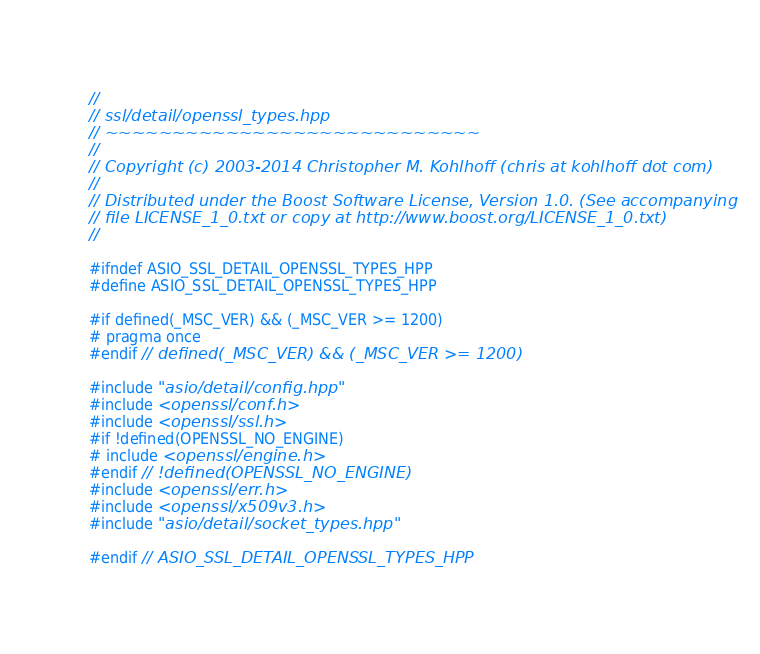<code> <loc_0><loc_0><loc_500><loc_500><_C++_>//
// ssl/detail/openssl_types.hpp
// ~~~~~~~~~~~~~~~~~~~~~~~~~~~~
//
// Copyright (c) 2003-2014 Christopher M. Kohlhoff (chris at kohlhoff dot com)
//
// Distributed under the Boost Software License, Version 1.0. (See accompanying
// file LICENSE_1_0.txt or copy at http://www.boost.org/LICENSE_1_0.txt)
//

#ifndef ASIO_SSL_DETAIL_OPENSSL_TYPES_HPP
#define ASIO_SSL_DETAIL_OPENSSL_TYPES_HPP

#if defined(_MSC_VER) && (_MSC_VER >= 1200)
# pragma once
#endif // defined(_MSC_VER) && (_MSC_VER >= 1200)

#include "asio/detail/config.hpp"
#include <openssl/conf.h>
#include <openssl/ssl.h>
#if !defined(OPENSSL_NO_ENGINE)
# include <openssl/engine.h>
#endif // !defined(OPENSSL_NO_ENGINE)
#include <openssl/err.h>
#include <openssl/x509v3.h>
#include "asio/detail/socket_types.hpp"

#endif // ASIO_SSL_DETAIL_OPENSSL_TYPES_HPP
</code> 